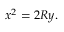<formula> <loc_0><loc_0><loc_500><loc_500>x ^ { 2 } = 2 R y .</formula> 